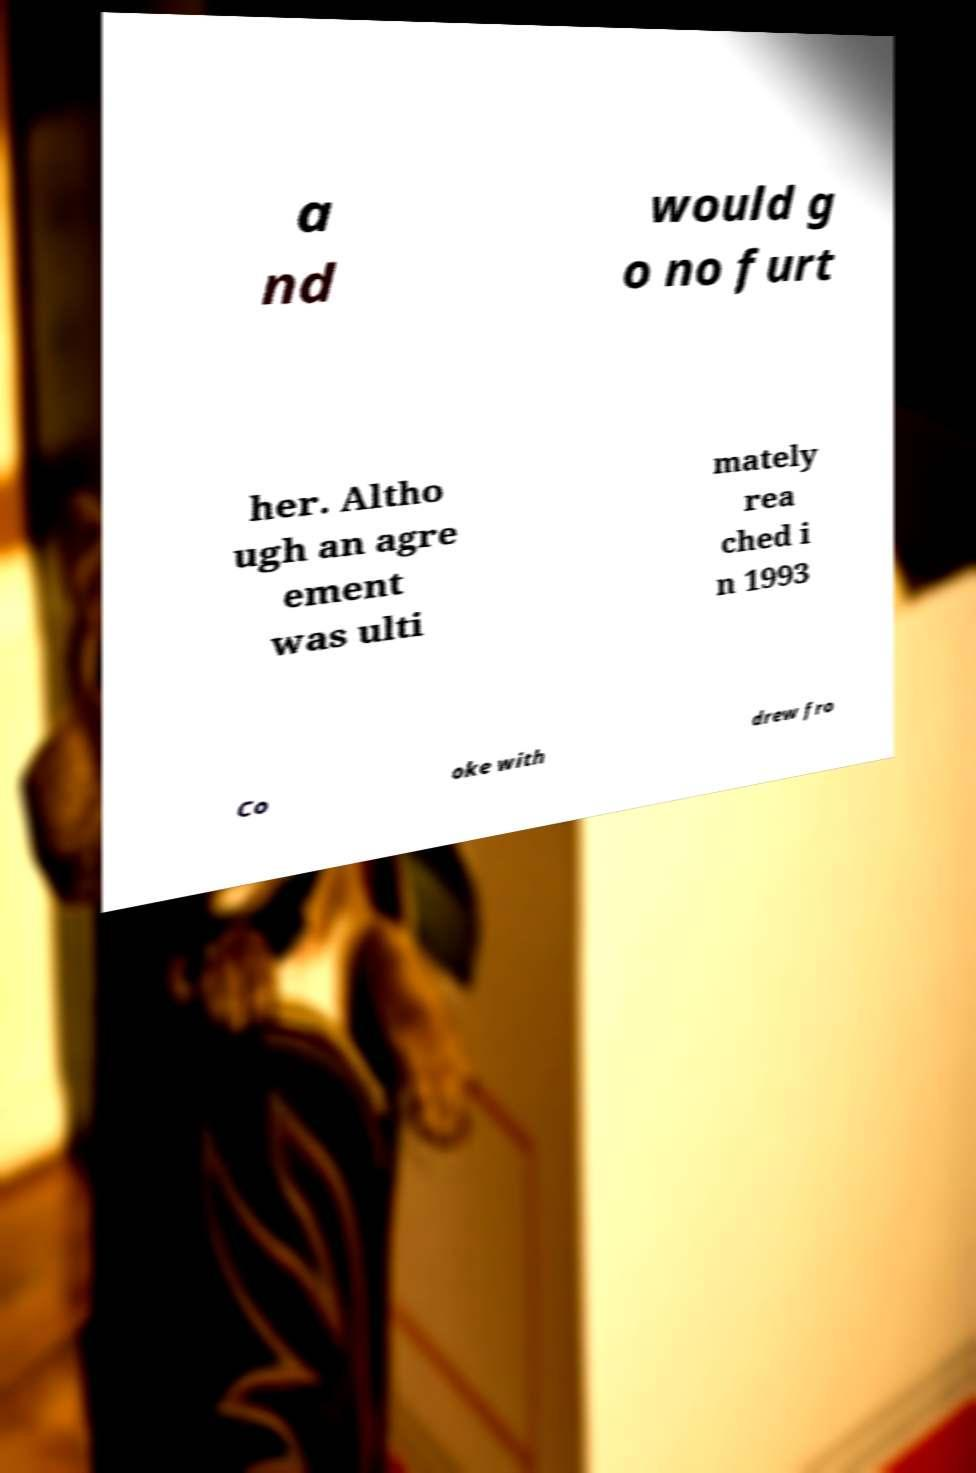Can you read and provide the text displayed in the image?This photo seems to have some interesting text. Can you extract and type it out for me? a nd would g o no furt her. Altho ugh an agre ement was ulti mately rea ched i n 1993 Co oke with drew fro 